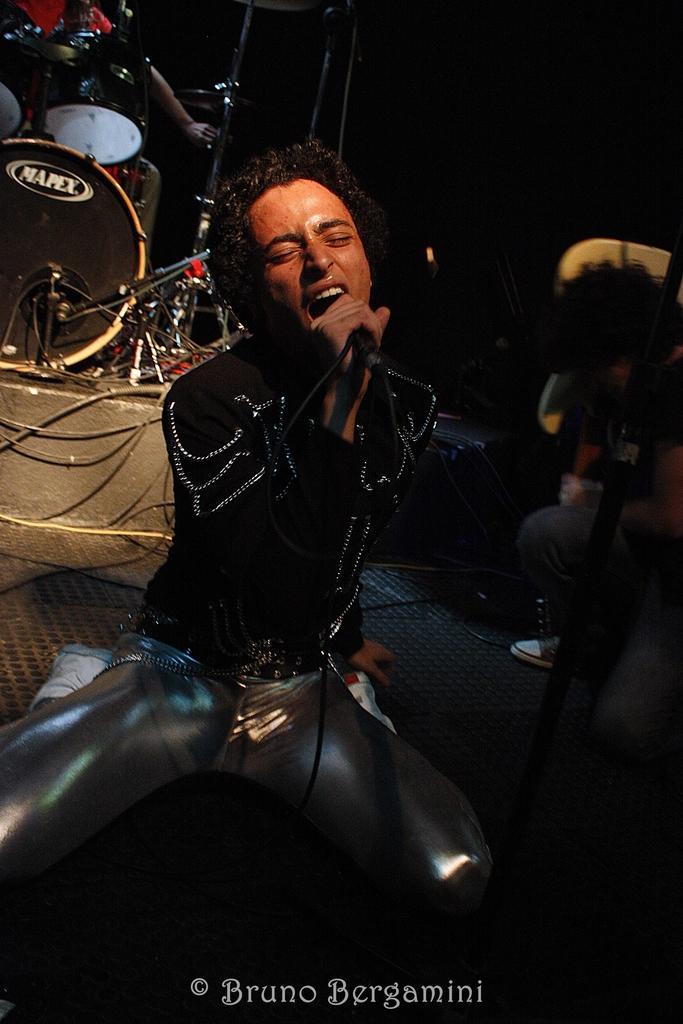Describe this image in one or two sentences. In this picture we can see a man who is sitting on the floor. He is singing on the mike. And in the background we can see some musical instruments. 